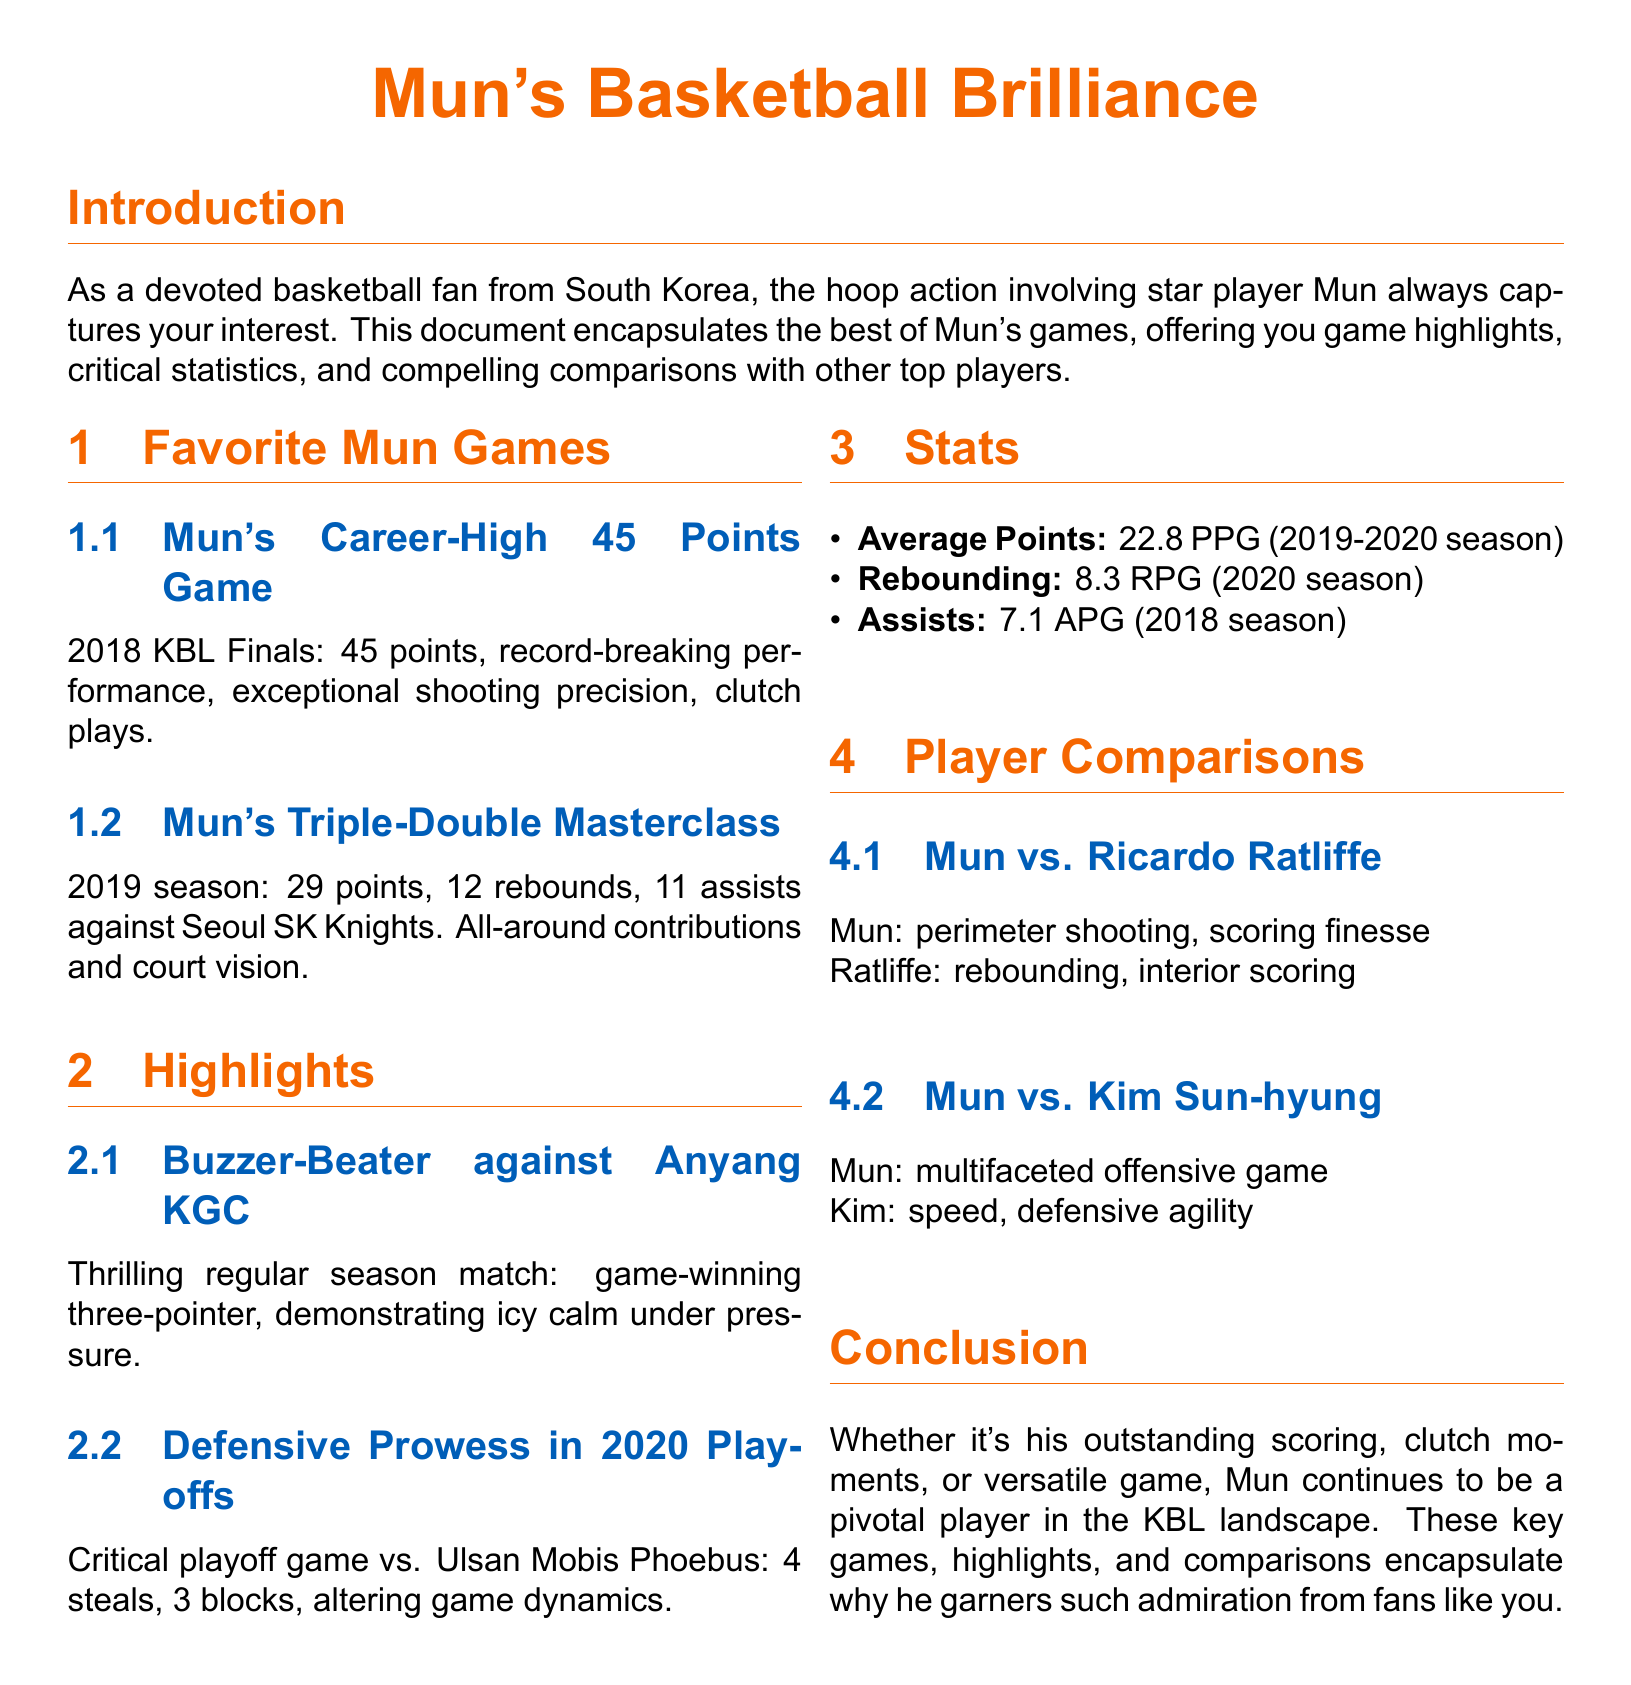what was Mun's career-high points in a game? Mun scored 45 points in the 2018 KBL Finals, marking his career-high performance.
Answer: 45 points what season did Mun achieve a triple-double? Mun achieved a triple-double during the 2019 season against the Seoul SK Knights.
Answer: 2019 season how many assists did Mun average in the 2018 season? Mun averaged 7.1 assists per game in the 2018 season.
Answer: 7.1 APG what key highlight involved a game-winning shot? The thrilling highlight involved a buzzer-beater against Anyang KGC.
Answer: Buzzer-Beater against Anyang KGC how many blocks did Mun make in the critical playoff game? Mun recorded 3 blocks in the critical playoff game vs. Ulsan Mobis Phoebus.
Answer: 3 blocks who is compared to Mun for perimeter shooting? Mun is compared to Ricardo Ratliffe for his perimeter shooting.
Answer: Ricardo Ratliffe what was Mun's average points per game in the 2019-2020 season? Mun's average points per game in the 2019-2020 season was 22.8.
Answer: 22.8 PPG what notable defensive statistic did Mun achieve in 2020? In 2020, Mun recorded 4 steals in a critical playoff game.
Answer: 4 steals which player is noted for speed and defensive agility in comparison to Mun? Kim Sun-hyung is noted for his speed and defensive agility in comparison to Mun.
Answer: Kim Sun-hyung 